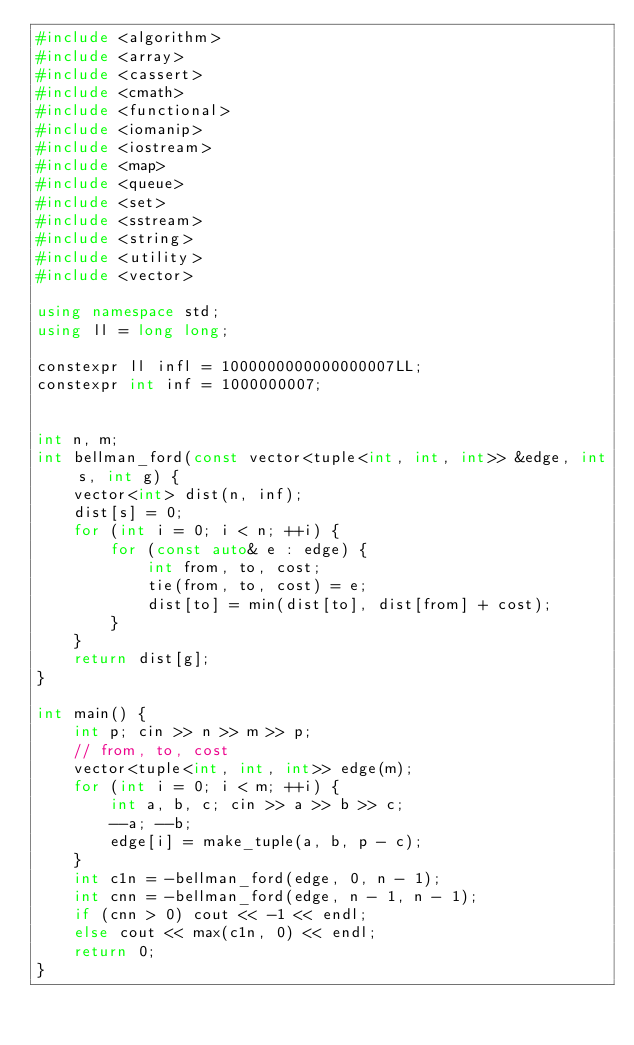<code> <loc_0><loc_0><loc_500><loc_500><_C++_>#include <algorithm>
#include <array>
#include <cassert>
#include <cmath>
#include <functional>
#include <iomanip>
#include <iostream>
#include <map>
#include <queue>
#include <set>
#include <sstream>
#include <string>
#include <utility>
#include <vector>

using namespace std;
using ll = long long;

constexpr ll infl = 1000000000000000007LL;
constexpr int inf = 1000000007;


int n, m;
int bellman_ford(const vector<tuple<int, int, int>> &edge, int s, int g) {
    vector<int> dist(n, inf);
    dist[s] = 0;
    for (int i = 0; i < n; ++i) {
        for (const auto& e : edge) {
            int from, to, cost;
            tie(from, to, cost) = e;
            dist[to] = min(dist[to], dist[from] + cost);
        }
    }
    return dist[g];
}

int main() {
    int p; cin >> n >> m >> p;
    // from, to, cost
    vector<tuple<int, int, int>> edge(m);
    for (int i = 0; i < m; ++i) {
        int a, b, c; cin >> a >> b >> c;
        --a; --b;
        edge[i] = make_tuple(a, b, p - c);
    }
    int c1n = -bellman_ford(edge, 0, n - 1);
    int cnn = -bellman_ford(edge, n - 1, n - 1);
    if (cnn > 0) cout << -1 << endl;
    else cout << max(c1n, 0) << endl;
    return 0;
}</code> 